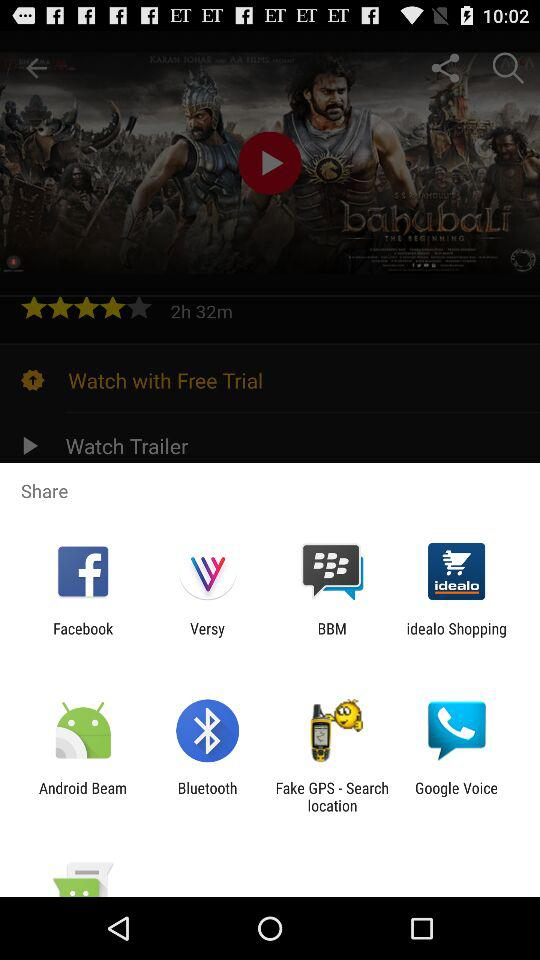What is the time duration? The time duration is 2 hours and 32 minutes. 